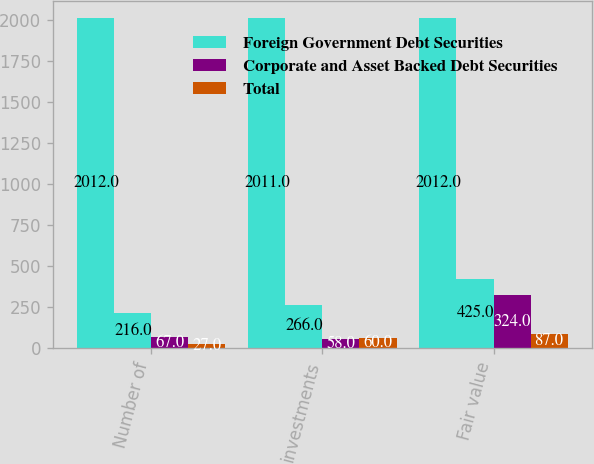Convert chart. <chart><loc_0><loc_0><loc_500><loc_500><stacked_bar_chart><ecel><fcel>Number of<fcel>investments<fcel>Fair value<nl><fcel>nan<fcel>2012<fcel>2011<fcel>2012<nl><fcel>Foreign Government Debt Securities<fcel>216<fcel>266<fcel>425<nl><fcel>Corporate and Asset Backed Debt Securities<fcel>67<fcel>58<fcel>324<nl><fcel>Total<fcel>27<fcel>60<fcel>87<nl></chart> 